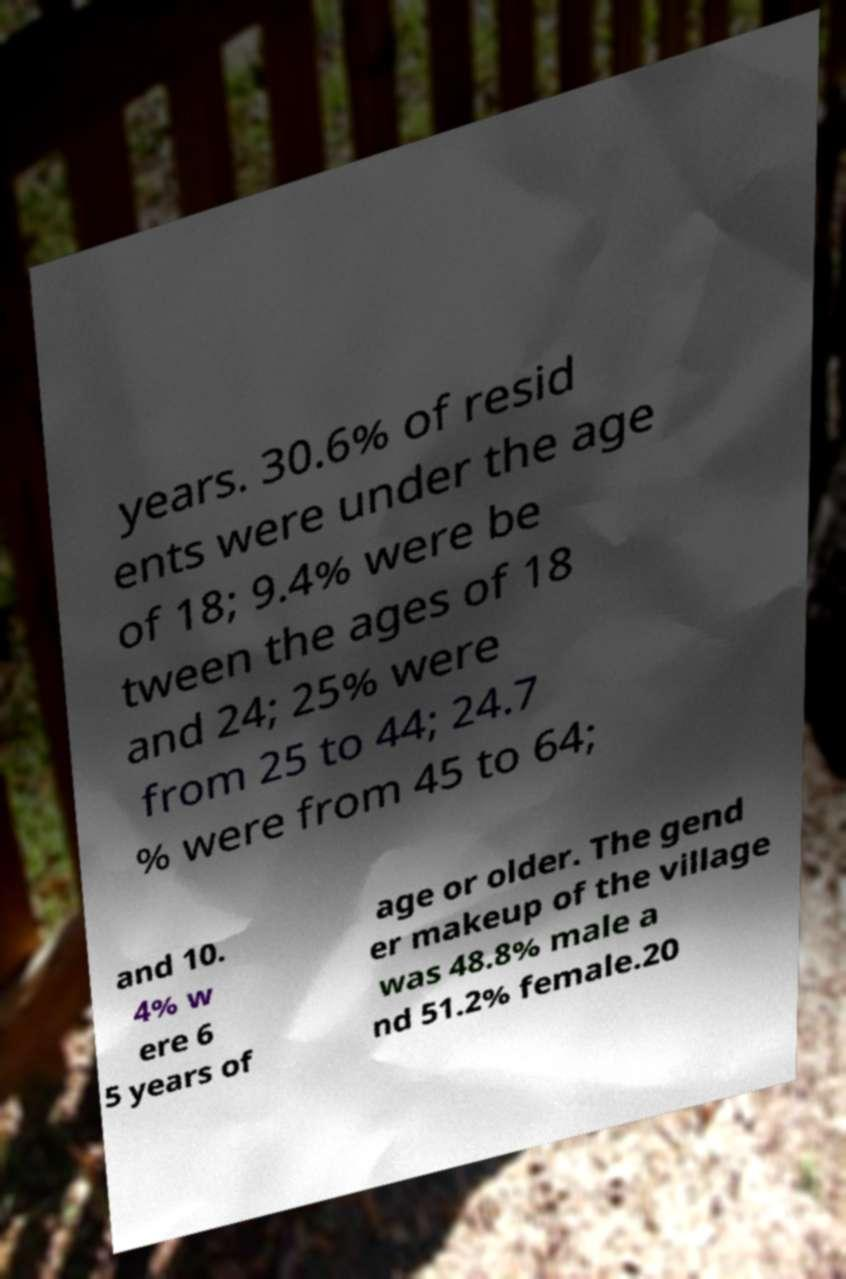Could you extract and type out the text from this image? years. 30.6% of resid ents were under the age of 18; 9.4% were be tween the ages of 18 and 24; 25% were from 25 to 44; 24.7 % were from 45 to 64; and 10. 4% w ere 6 5 years of age or older. The gend er makeup of the village was 48.8% male a nd 51.2% female.20 